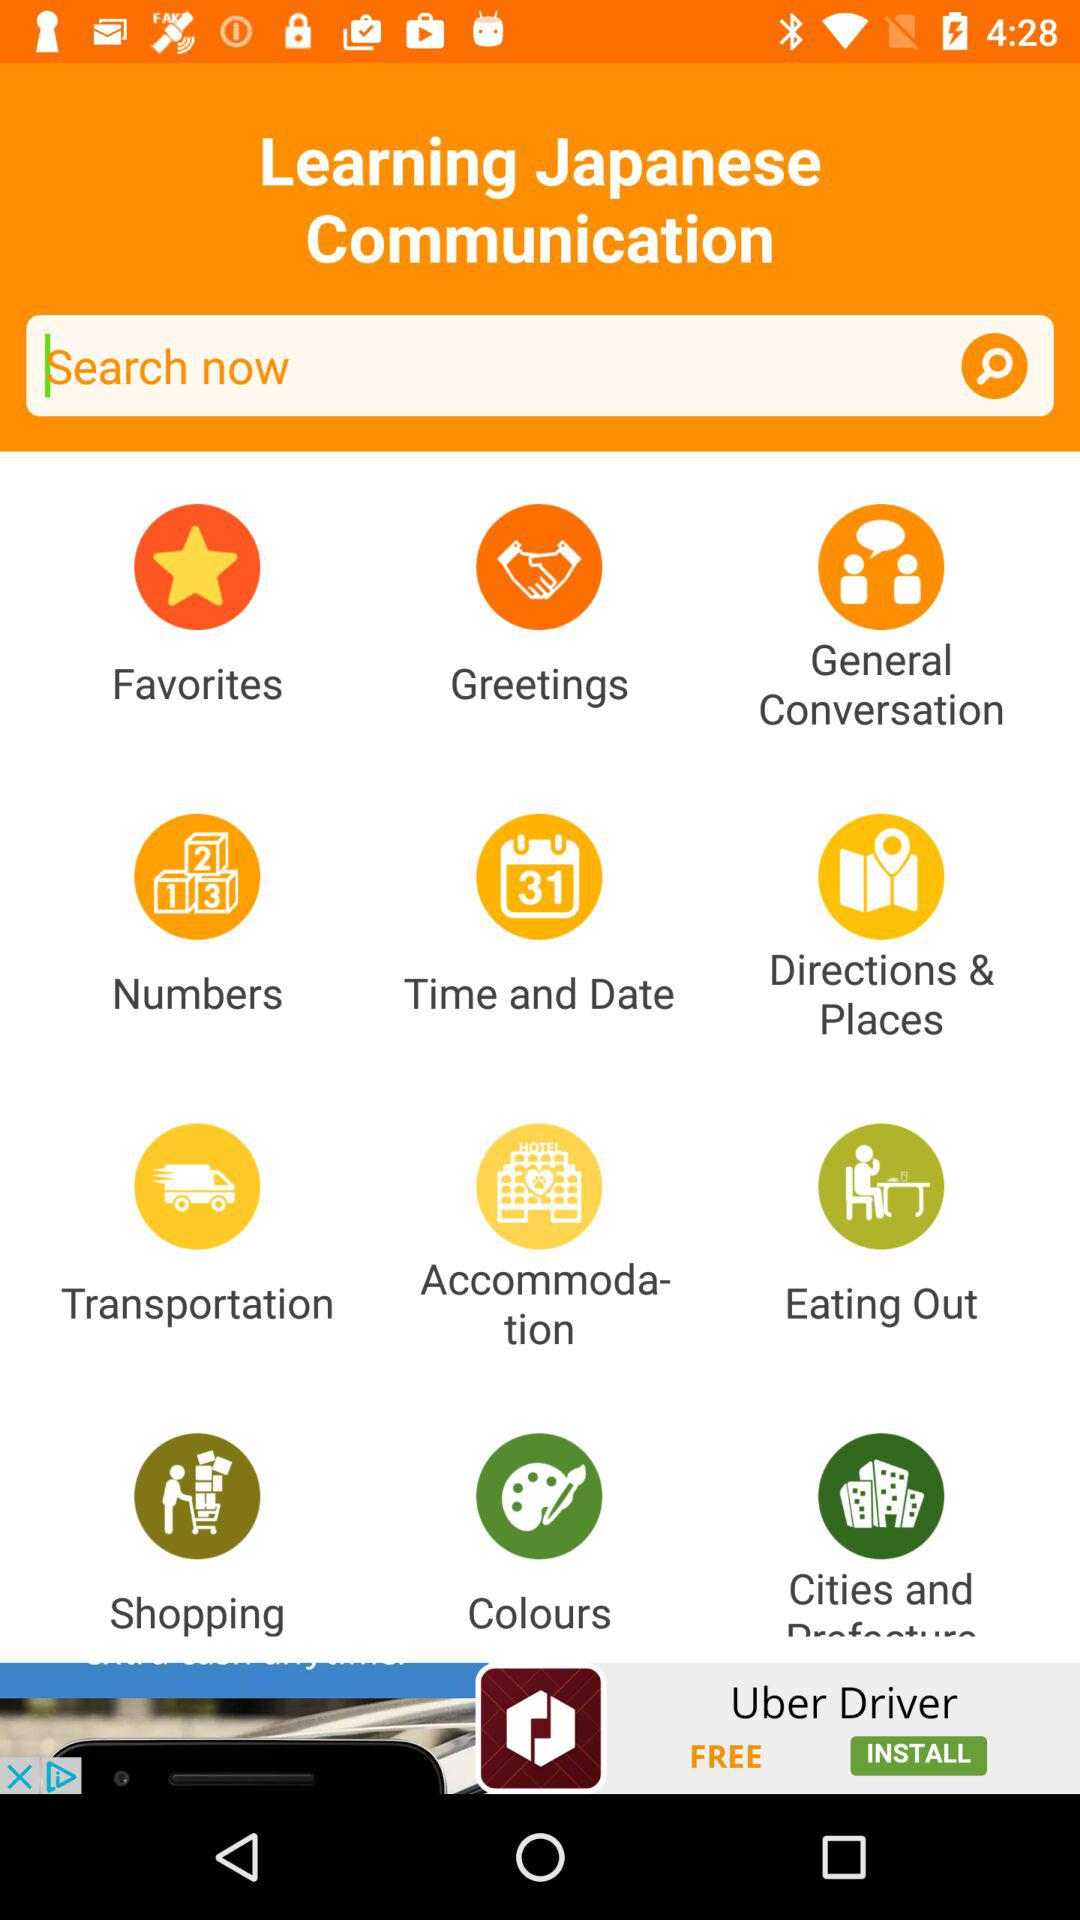What is the name of the application? The application name is "Learn Japanese Communication". 